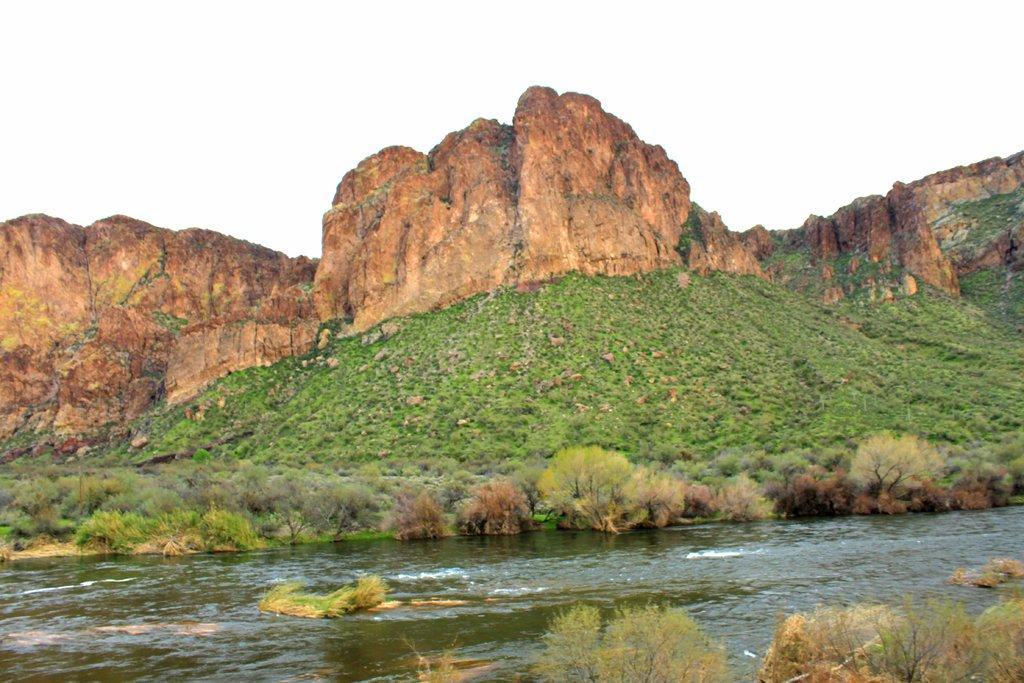Describe this image in one or two sentences. In this image I see the water and I see many plants and I see the grass and I see the rocky mountains. In the background I see the clear sky. 